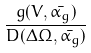Convert formula to latex. <formula><loc_0><loc_0><loc_500><loc_500>\frac { g ( V , \bar { \alpha _ { g } } ) } { D ( \Delta \Omega , \bar { \alpha _ { g } } ) }</formula> 